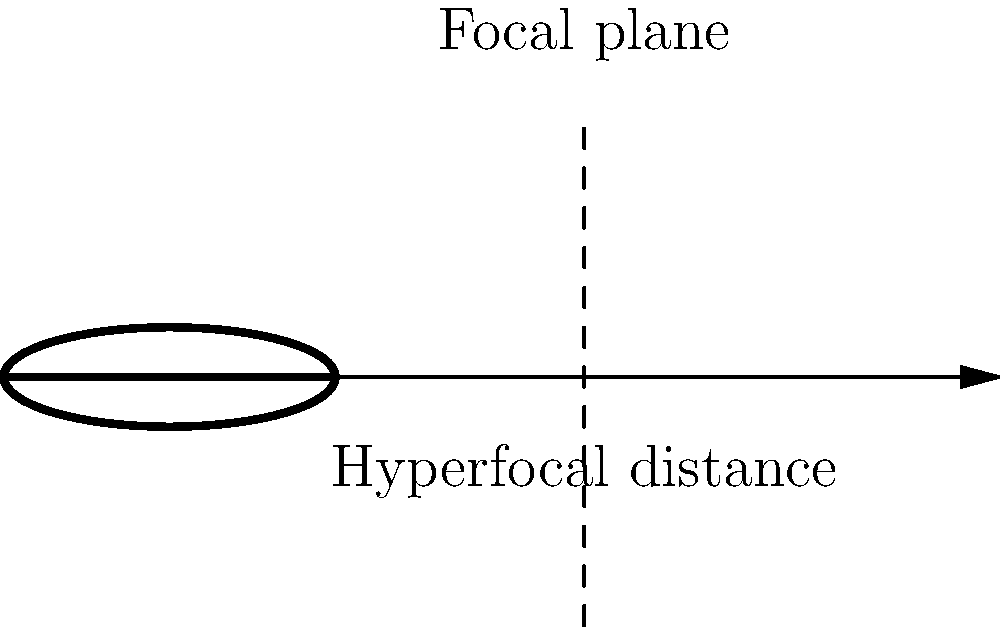As an experienced landscape photographer, you know the importance of hyperfocal distance in achieving sharp images. Given a lens with a focal length of 24mm and an aperture of f/11, calculate the hyperfocal distance. Assume the circle of confusion is 0.03mm for a full-frame camera. Round your answer to the nearest centimeter. To calculate the hyperfocal distance, we'll use the formula:

$$ H = \frac{f^2}{N \cdot c} + f $$

Where:
$H$ = Hyperfocal distance
$f$ = Focal length
$N$ = f-number (aperture)
$c$ = Circle of confusion

Step 1: Insert the given values into the formula
$f = 24\text{ mm}$
$N = 11$
$c = 0.03\text{ mm}$

Step 2: Calculate the numerator
$f^2 = 24^2 = 576\text{ mm}^2$

Step 3: Calculate the denominator
$N \cdot c = 11 \cdot 0.03 = 0.33\text{ mm}$

Step 4: Divide the numerator by the denominator
$\frac{576}{0.33} \approx 1745.45\text{ mm}$

Step 5: Add the focal length
$1745.45 + 24 = 1769.45\text{ mm}$

Step 6: Convert to centimeters and round to the nearest centimeter
$1769.45\text{ mm} \approx 176.95\text{ cm} \approx 177\text{ cm}$

Therefore, the hyperfocal distance is approximately 177 cm or 1.77 m.
Answer: 177 cm 